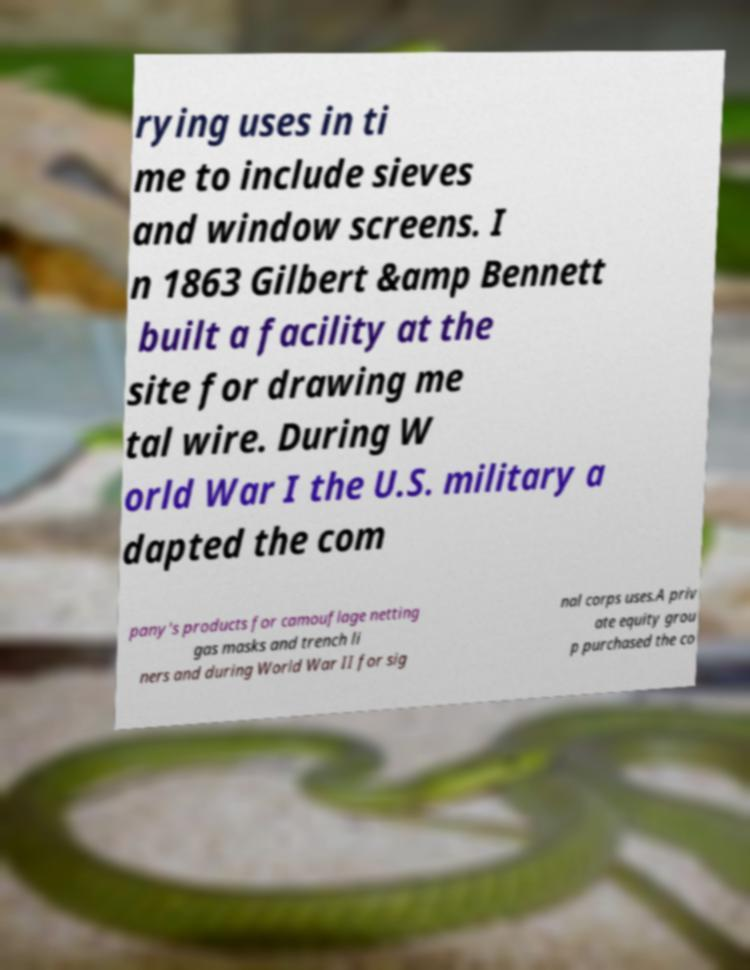What messages or text are displayed in this image? I need them in a readable, typed format. rying uses in ti me to include sieves and window screens. I n 1863 Gilbert &amp Bennett built a facility at the site for drawing me tal wire. During W orld War I the U.S. military a dapted the com pany's products for camouflage netting gas masks and trench li ners and during World War II for sig nal corps uses.A priv ate equity grou p purchased the co 